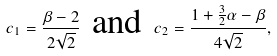<formula> <loc_0><loc_0><loc_500><loc_500>c _ { 1 } = \frac { \beta - 2 } { 2 \sqrt { 2 } } \, \text { and } \, c _ { 2 } = \frac { 1 + \frac { 3 } { 2 } \alpha - \beta } { 4 \sqrt { 2 } } ,</formula> 